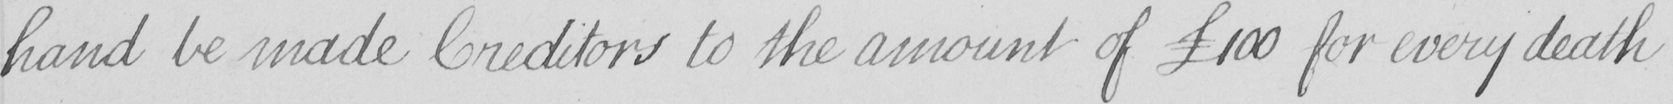What does this handwritten line say? hand be made Creditors to the amount of  £100 for every death 